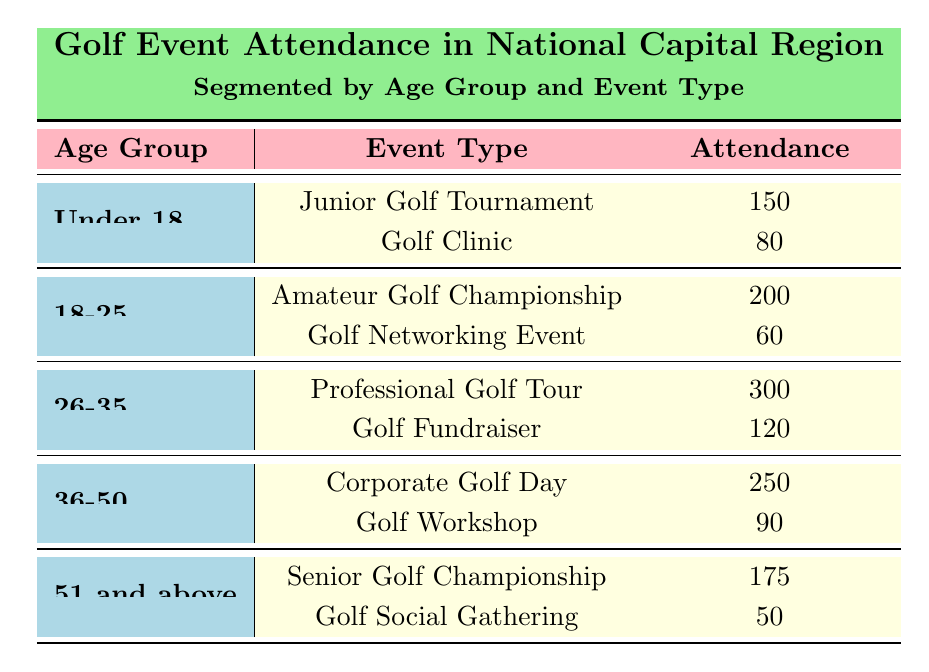What is the attendance for the Junior Golf Tournament? The table indicates that for the age group "Under 18", the event type "Junior Golf Tournament" has an attendance of 150.
Answer: 150 What age group has the highest attendance at golf events? The "26-35" age group has the highest attendance with a total of 420 (300 for Professional Golf Tour and 120 for Golf Fundraiser) which is greater than all other age groups.
Answer: 26-35 Is the attendance for the Golf Social Gathering higher than the Golf Networking Event? The table shows the attendance for "Golf Social Gathering" (50) and for "Golf Networking Event" (60). Since 50 is less than 60, the attendance for the Golf Social Gathering is not higher.
Answer: No What is the total attendance for golfers aged 51 and above? To determine this, add the attendance for both events in the "51 and above" age group: 175 (Senior Golf Championship) + 50 (Golf Social Gathering) = 225.
Answer: 225 Which event has the lowest attendance? Reviewing all attendance values, the lowest is for the "Golf Social Gathering" with an attendance of 50, which is lower than all other events listed.
Answer: 50 What is the combined attendance for the age group 18-25? For the "18-25" age group, add the two values: 200 (Amateur Golf Championship) + 60 (Golf Networking Event) = 260.
Answer: 260 Is there an event where attendance exceeds 300? The data shows that the "Professional Golf Tour" has an attendance of 300, which does not exceed 300. Therefore, there is no event with attendance exceeding this value.
Answer: No What percentage of attendees in the "Under 18" age group participated in the Golf Clinic? The total attendance in the "Under 18" age group is 230 (150 for Junior Golf Tournament + 80 for Golf Clinic). The percentage for the Golf Clinic is then (80 / 230) * 100 ≈ 34.78%.
Answer: 34.78% Which age group has the second-highest attendance? The second-highest attendance is for the "36-50" age group, totaling 340 (250 for Corporate Golf Day and 90 for Golf Workshop), which is less than the 26-35 age group but higher than the others.
Answer: 36-50 